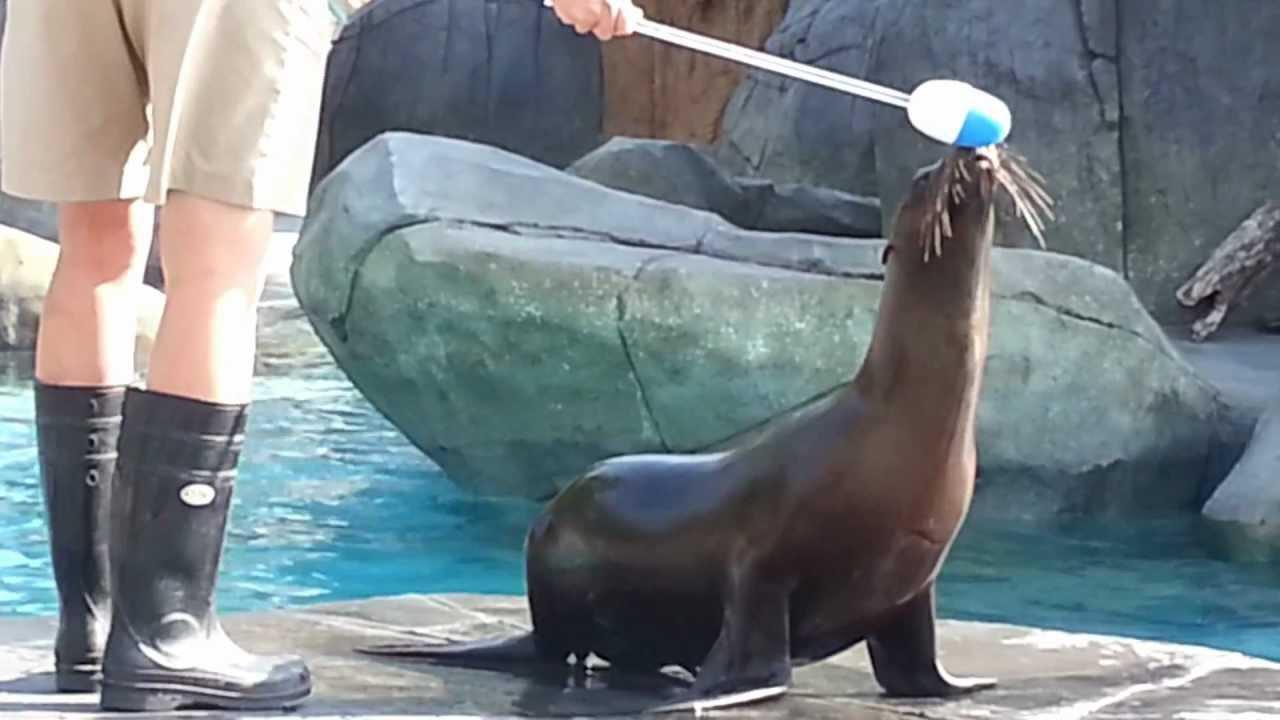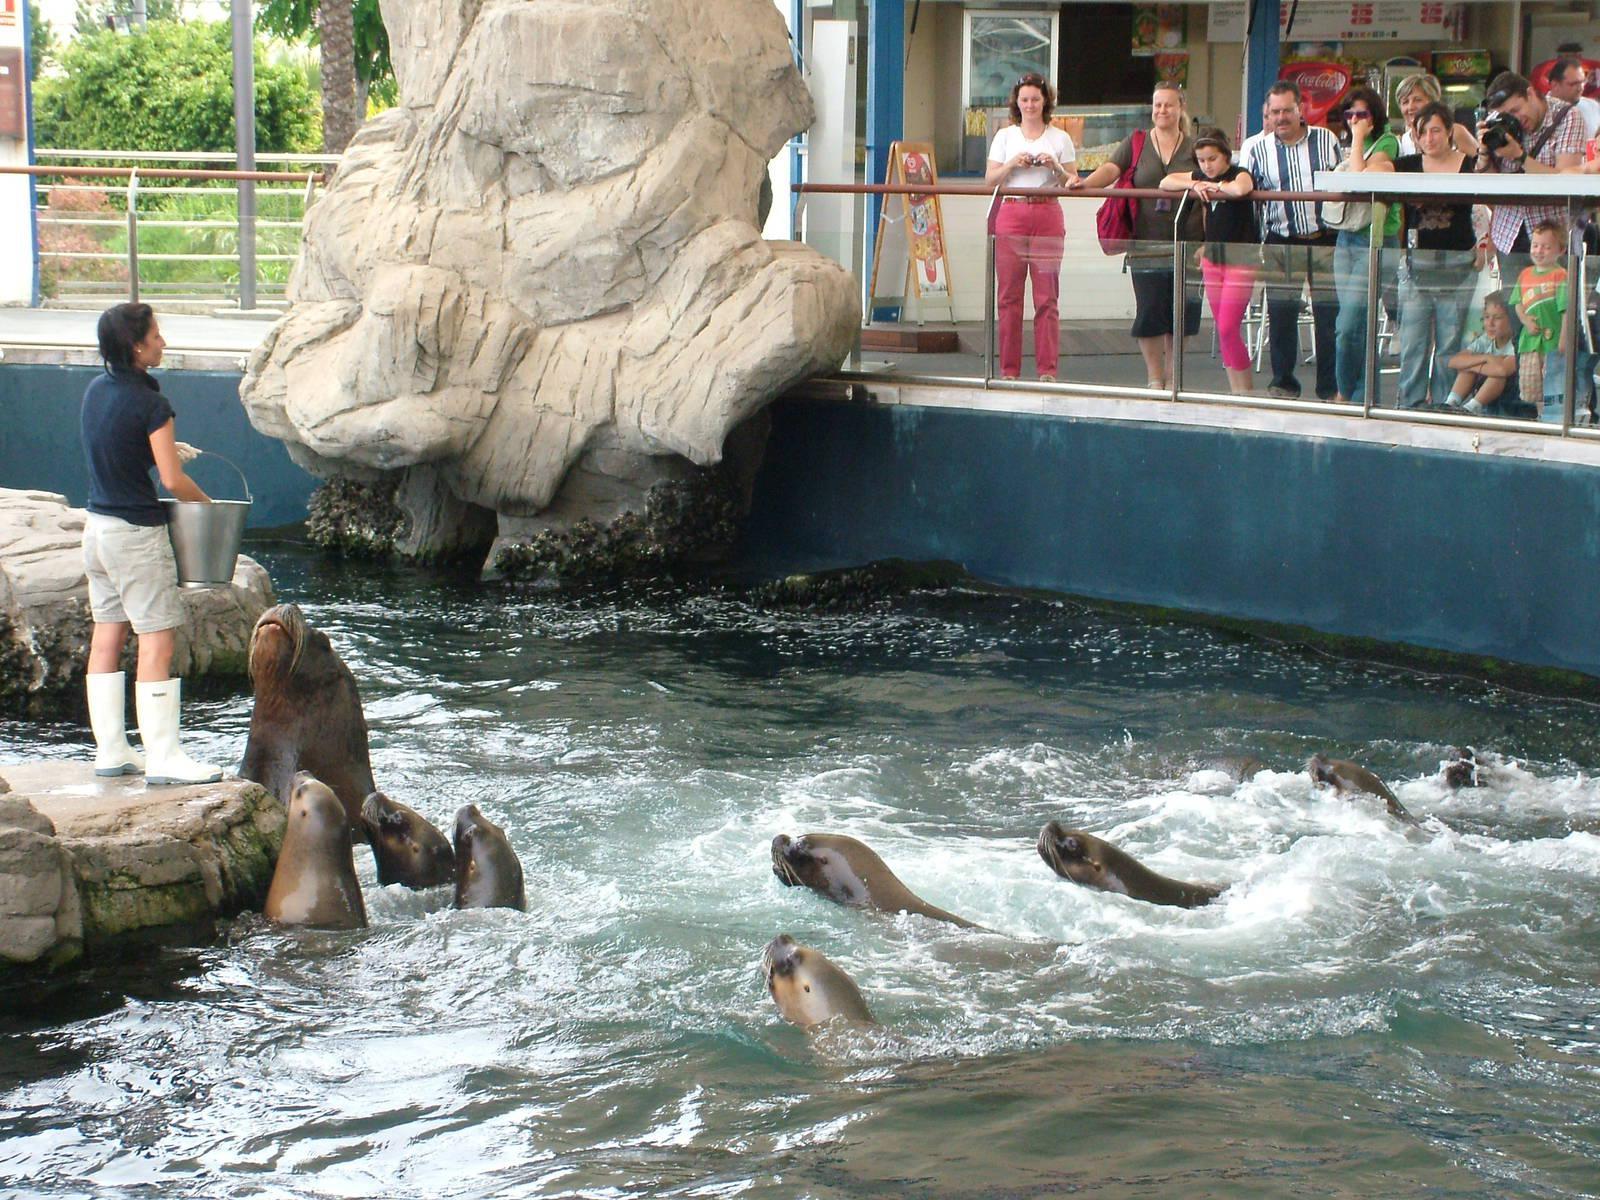The first image is the image on the left, the second image is the image on the right. Given the left and right images, does the statement "A sea lion is looking over a boat where a woman sits." hold true? Answer yes or no. No. 